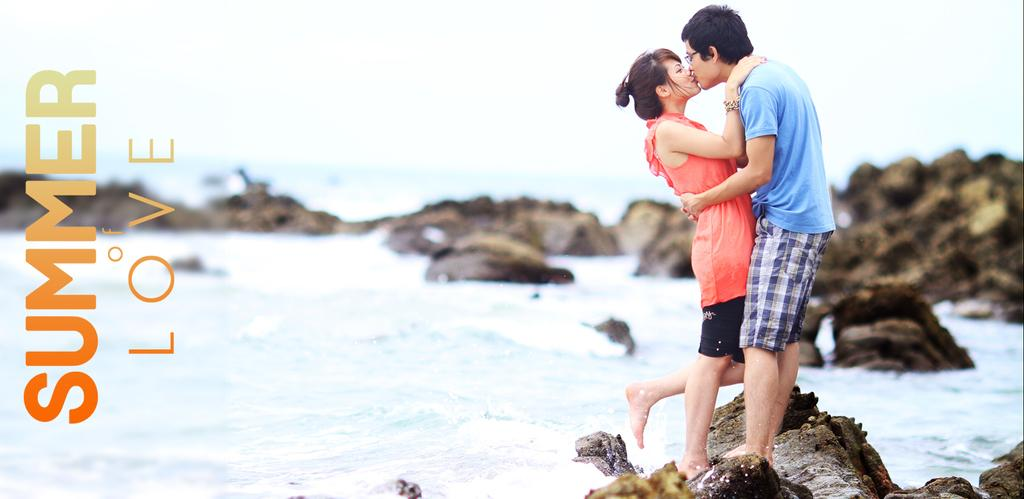Who is present in the image? There is a couple in the image. What are they doing in the image? The couple is standing on a rock and kissing. What can be seen in the background of the image? There are rocks in the water in the image. What type of bone can be seen in the image? There is no bone present in the image. How high are the couple jumping in the image? The couple is not jumping in the image; they are standing on a rock and kissing. 